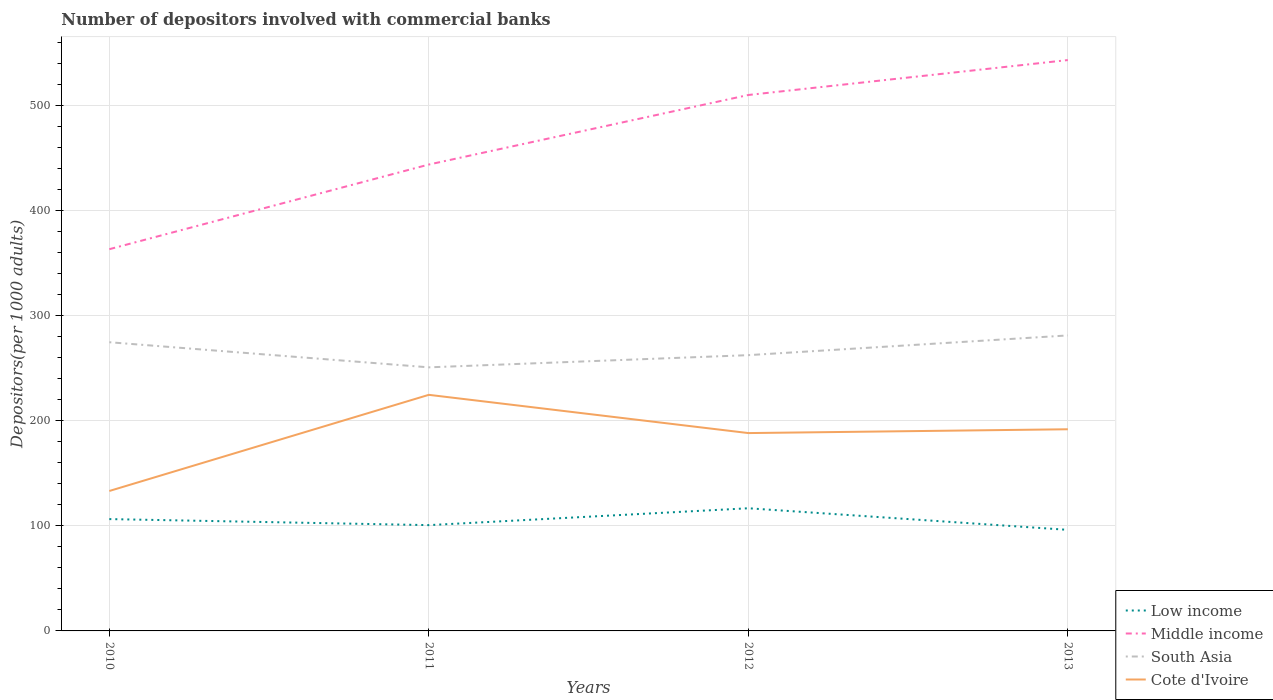Across all years, what is the maximum number of depositors involved with commercial banks in Middle income?
Give a very brief answer. 363.5. In which year was the number of depositors involved with commercial banks in Middle income maximum?
Ensure brevity in your answer.  2010. What is the total number of depositors involved with commercial banks in South Asia in the graph?
Your answer should be compact. 12.31. What is the difference between the highest and the second highest number of depositors involved with commercial banks in Low income?
Provide a succinct answer. 20.56. What is the difference between the highest and the lowest number of depositors involved with commercial banks in Low income?
Your answer should be compact. 2. Is the number of depositors involved with commercial banks in South Asia strictly greater than the number of depositors involved with commercial banks in Middle income over the years?
Make the answer very short. Yes. How many lines are there?
Your answer should be compact. 4. What is the difference between two consecutive major ticks on the Y-axis?
Your response must be concise. 100. Are the values on the major ticks of Y-axis written in scientific E-notation?
Your answer should be compact. No. Where does the legend appear in the graph?
Provide a short and direct response. Bottom right. How are the legend labels stacked?
Your response must be concise. Vertical. What is the title of the graph?
Your answer should be very brief. Number of depositors involved with commercial banks. What is the label or title of the X-axis?
Your answer should be compact. Years. What is the label or title of the Y-axis?
Keep it short and to the point. Depositors(per 1000 adults). What is the Depositors(per 1000 adults) of Low income in 2010?
Provide a succinct answer. 106.49. What is the Depositors(per 1000 adults) in Middle income in 2010?
Keep it short and to the point. 363.5. What is the Depositors(per 1000 adults) in South Asia in 2010?
Your response must be concise. 274.9. What is the Depositors(per 1000 adults) in Cote d'Ivoire in 2010?
Your answer should be very brief. 133.26. What is the Depositors(per 1000 adults) of Low income in 2011?
Provide a succinct answer. 100.75. What is the Depositors(per 1000 adults) in Middle income in 2011?
Make the answer very short. 444.11. What is the Depositors(per 1000 adults) of South Asia in 2011?
Ensure brevity in your answer.  250.99. What is the Depositors(per 1000 adults) of Cote d'Ivoire in 2011?
Keep it short and to the point. 224.81. What is the Depositors(per 1000 adults) in Low income in 2012?
Provide a succinct answer. 116.8. What is the Depositors(per 1000 adults) of Middle income in 2012?
Give a very brief answer. 510.34. What is the Depositors(per 1000 adults) in South Asia in 2012?
Offer a terse response. 262.6. What is the Depositors(per 1000 adults) in Cote d'Ivoire in 2012?
Ensure brevity in your answer.  188.4. What is the Depositors(per 1000 adults) in Low income in 2013?
Keep it short and to the point. 96.24. What is the Depositors(per 1000 adults) of Middle income in 2013?
Provide a succinct answer. 543.59. What is the Depositors(per 1000 adults) in South Asia in 2013?
Your response must be concise. 281.38. What is the Depositors(per 1000 adults) in Cote d'Ivoire in 2013?
Offer a terse response. 192.03. Across all years, what is the maximum Depositors(per 1000 adults) in Low income?
Ensure brevity in your answer.  116.8. Across all years, what is the maximum Depositors(per 1000 adults) of Middle income?
Provide a short and direct response. 543.59. Across all years, what is the maximum Depositors(per 1000 adults) of South Asia?
Your response must be concise. 281.38. Across all years, what is the maximum Depositors(per 1000 adults) in Cote d'Ivoire?
Your answer should be very brief. 224.81. Across all years, what is the minimum Depositors(per 1000 adults) of Low income?
Offer a terse response. 96.24. Across all years, what is the minimum Depositors(per 1000 adults) of Middle income?
Offer a very short reply. 363.5. Across all years, what is the minimum Depositors(per 1000 adults) of South Asia?
Give a very brief answer. 250.99. Across all years, what is the minimum Depositors(per 1000 adults) of Cote d'Ivoire?
Your answer should be compact. 133.26. What is the total Depositors(per 1000 adults) of Low income in the graph?
Give a very brief answer. 420.28. What is the total Depositors(per 1000 adults) of Middle income in the graph?
Provide a short and direct response. 1861.53. What is the total Depositors(per 1000 adults) of South Asia in the graph?
Your response must be concise. 1069.88. What is the total Depositors(per 1000 adults) in Cote d'Ivoire in the graph?
Make the answer very short. 738.5. What is the difference between the Depositors(per 1000 adults) in Low income in 2010 and that in 2011?
Provide a succinct answer. 5.74. What is the difference between the Depositors(per 1000 adults) of Middle income in 2010 and that in 2011?
Your answer should be very brief. -80.61. What is the difference between the Depositors(per 1000 adults) in South Asia in 2010 and that in 2011?
Your answer should be compact. 23.91. What is the difference between the Depositors(per 1000 adults) in Cote d'Ivoire in 2010 and that in 2011?
Your answer should be compact. -91.56. What is the difference between the Depositors(per 1000 adults) in Low income in 2010 and that in 2012?
Your response must be concise. -10.31. What is the difference between the Depositors(per 1000 adults) of Middle income in 2010 and that in 2012?
Your answer should be very brief. -146.84. What is the difference between the Depositors(per 1000 adults) in South Asia in 2010 and that in 2012?
Ensure brevity in your answer.  12.31. What is the difference between the Depositors(per 1000 adults) in Cote d'Ivoire in 2010 and that in 2012?
Offer a terse response. -55.14. What is the difference between the Depositors(per 1000 adults) of Low income in 2010 and that in 2013?
Give a very brief answer. 10.25. What is the difference between the Depositors(per 1000 adults) of Middle income in 2010 and that in 2013?
Ensure brevity in your answer.  -180.09. What is the difference between the Depositors(per 1000 adults) in South Asia in 2010 and that in 2013?
Ensure brevity in your answer.  -6.48. What is the difference between the Depositors(per 1000 adults) in Cote d'Ivoire in 2010 and that in 2013?
Your answer should be compact. -58.78. What is the difference between the Depositors(per 1000 adults) of Low income in 2011 and that in 2012?
Offer a terse response. -16.05. What is the difference between the Depositors(per 1000 adults) of Middle income in 2011 and that in 2012?
Your answer should be compact. -66.23. What is the difference between the Depositors(per 1000 adults) of South Asia in 2011 and that in 2012?
Keep it short and to the point. -11.61. What is the difference between the Depositors(per 1000 adults) of Cote d'Ivoire in 2011 and that in 2012?
Your answer should be compact. 36.42. What is the difference between the Depositors(per 1000 adults) in Low income in 2011 and that in 2013?
Provide a short and direct response. 4.5. What is the difference between the Depositors(per 1000 adults) in Middle income in 2011 and that in 2013?
Offer a terse response. -99.48. What is the difference between the Depositors(per 1000 adults) of South Asia in 2011 and that in 2013?
Your answer should be compact. -30.39. What is the difference between the Depositors(per 1000 adults) in Cote d'Ivoire in 2011 and that in 2013?
Give a very brief answer. 32.78. What is the difference between the Depositors(per 1000 adults) in Low income in 2012 and that in 2013?
Provide a short and direct response. 20.56. What is the difference between the Depositors(per 1000 adults) in Middle income in 2012 and that in 2013?
Keep it short and to the point. -33.25. What is the difference between the Depositors(per 1000 adults) of South Asia in 2012 and that in 2013?
Keep it short and to the point. -18.78. What is the difference between the Depositors(per 1000 adults) of Cote d'Ivoire in 2012 and that in 2013?
Provide a short and direct response. -3.63. What is the difference between the Depositors(per 1000 adults) in Low income in 2010 and the Depositors(per 1000 adults) in Middle income in 2011?
Ensure brevity in your answer.  -337.62. What is the difference between the Depositors(per 1000 adults) in Low income in 2010 and the Depositors(per 1000 adults) in South Asia in 2011?
Your answer should be very brief. -144.5. What is the difference between the Depositors(per 1000 adults) of Low income in 2010 and the Depositors(per 1000 adults) of Cote d'Ivoire in 2011?
Give a very brief answer. -118.32. What is the difference between the Depositors(per 1000 adults) in Middle income in 2010 and the Depositors(per 1000 adults) in South Asia in 2011?
Provide a short and direct response. 112.5. What is the difference between the Depositors(per 1000 adults) of Middle income in 2010 and the Depositors(per 1000 adults) of Cote d'Ivoire in 2011?
Provide a succinct answer. 138.68. What is the difference between the Depositors(per 1000 adults) of South Asia in 2010 and the Depositors(per 1000 adults) of Cote d'Ivoire in 2011?
Your answer should be compact. 50.09. What is the difference between the Depositors(per 1000 adults) in Low income in 2010 and the Depositors(per 1000 adults) in Middle income in 2012?
Offer a very short reply. -403.85. What is the difference between the Depositors(per 1000 adults) of Low income in 2010 and the Depositors(per 1000 adults) of South Asia in 2012?
Provide a succinct answer. -156.11. What is the difference between the Depositors(per 1000 adults) of Low income in 2010 and the Depositors(per 1000 adults) of Cote d'Ivoire in 2012?
Your answer should be compact. -81.91. What is the difference between the Depositors(per 1000 adults) in Middle income in 2010 and the Depositors(per 1000 adults) in South Asia in 2012?
Offer a very short reply. 100.9. What is the difference between the Depositors(per 1000 adults) of Middle income in 2010 and the Depositors(per 1000 adults) of Cote d'Ivoire in 2012?
Your answer should be compact. 175.1. What is the difference between the Depositors(per 1000 adults) in South Asia in 2010 and the Depositors(per 1000 adults) in Cote d'Ivoire in 2012?
Your response must be concise. 86.51. What is the difference between the Depositors(per 1000 adults) in Low income in 2010 and the Depositors(per 1000 adults) in Middle income in 2013?
Your answer should be compact. -437.1. What is the difference between the Depositors(per 1000 adults) in Low income in 2010 and the Depositors(per 1000 adults) in South Asia in 2013?
Your answer should be very brief. -174.89. What is the difference between the Depositors(per 1000 adults) of Low income in 2010 and the Depositors(per 1000 adults) of Cote d'Ivoire in 2013?
Offer a terse response. -85.54. What is the difference between the Depositors(per 1000 adults) in Middle income in 2010 and the Depositors(per 1000 adults) in South Asia in 2013?
Your answer should be compact. 82.12. What is the difference between the Depositors(per 1000 adults) in Middle income in 2010 and the Depositors(per 1000 adults) in Cote d'Ivoire in 2013?
Your answer should be compact. 171.47. What is the difference between the Depositors(per 1000 adults) of South Asia in 2010 and the Depositors(per 1000 adults) of Cote d'Ivoire in 2013?
Your response must be concise. 82.87. What is the difference between the Depositors(per 1000 adults) of Low income in 2011 and the Depositors(per 1000 adults) of Middle income in 2012?
Make the answer very short. -409.59. What is the difference between the Depositors(per 1000 adults) of Low income in 2011 and the Depositors(per 1000 adults) of South Asia in 2012?
Offer a very short reply. -161.85. What is the difference between the Depositors(per 1000 adults) in Low income in 2011 and the Depositors(per 1000 adults) in Cote d'Ivoire in 2012?
Ensure brevity in your answer.  -87.65. What is the difference between the Depositors(per 1000 adults) in Middle income in 2011 and the Depositors(per 1000 adults) in South Asia in 2012?
Provide a short and direct response. 181.51. What is the difference between the Depositors(per 1000 adults) in Middle income in 2011 and the Depositors(per 1000 adults) in Cote d'Ivoire in 2012?
Keep it short and to the point. 255.71. What is the difference between the Depositors(per 1000 adults) in South Asia in 2011 and the Depositors(per 1000 adults) in Cote d'Ivoire in 2012?
Offer a terse response. 62.6. What is the difference between the Depositors(per 1000 adults) of Low income in 2011 and the Depositors(per 1000 adults) of Middle income in 2013?
Keep it short and to the point. -442.84. What is the difference between the Depositors(per 1000 adults) of Low income in 2011 and the Depositors(per 1000 adults) of South Asia in 2013?
Make the answer very short. -180.63. What is the difference between the Depositors(per 1000 adults) of Low income in 2011 and the Depositors(per 1000 adults) of Cote d'Ivoire in 2013?
Give a very brief answer. -91.28. What is the difference between the Depositors(per 1000 adults) in Middle income in 2011 and the Depositors(per 1000 adults) in South Asia in 2013?
Your answer should be compact. 162.73. What is the difference between the Depositors(per 1000 adults) of Middle income in 2011 and the Depositors(per 1000 adults) of Cote d'Ivoire in 2013?
Your answer should be compact. 252.08. What is the difference between the Depositors(per 1000 adults) of South Asia in 2011 and the Depositors(per 1000 adults) of Cote d'Ivoire in 2013?
Offer a terse response. 58.96. What is the difference between the Depositors(per 1000 adults) in Low income in 2012 and the Depositors(per 1000 adults) in Middle income in 2013?
Provide a succinct answer. -426.79. What is the difference between the Depositors(per 1000 adults) in Low income in 2012 and the Depositors(per 1000 adults) in South Asia in 2013?
Your answer should be compact. -164.58. What is the difference between the Depositors(per 1000 adults) of Low income in 2012 and the Depositors(per 1000 adults) of Cote d'Ivoire in 2013?
Provide a short and direct response. -75.23. What is the difference between the Depositors(per 1000 adults) of Middle income in 2012 and the Depositors(per 1000 adults) of South Asia in 2013?
Ensure brevity in your answer.  228.96. What is the difference between the Depositors(per 1000 adults) of Middle income in 2012 and the Depositors(per 1000 adults) of Cote d'Ivoire in 2013?
Ensure brevity in your answer.  318.3. What is the difference between the Depositors(per 1000 adults) in South Asia in 2012 and the Depositors(per 1000 adults) in Cote d'Ivoire in 2013?
Offer a very short reply. 70.57. What is the average Depositors(per 1000 adults) of Low income per year?
Provide a succinct answer. 105.07. What is the average Depositors(per 1000 adults) in Middle income per year?
Ensure brevity in your answer.  465.38. What is the average Depositors(per 1000 adults) of South Asia per year?
Offer a terse response. 267.47. What is the average Depositors(per 1000 adults) of Cote d'Ivoire per year?
Offer a very short reply. 184.62. In the year 2010, what is the difference between the Depositors(per 1000 adults) in Low income and Depositors(per 1000 adults) in Middle income?
Make the answer very short. -257.01. In the year 2010, what is the difference between the Depositors(per 1000 adults) of Low income and Depositors(per 1000 adults) of South Asia?
Your answer should be very brief. -168.41. In the year 2010, what is the difference between the Depositors(per 1000 adults) in Low income and Depositors(per 1000 adults) in Cote d'Ivoire?
Make the answer very short. -26.77. In the year 2010, what is the difference between the Depositors(per 1000 adults) in Middle income and Depositors(per 1000 adults) in South Asia?
Give a very brief answer. 88.59. In the year 2010, what is the difference between the Depositors(per 1000 adults) of Middle income and Depositors(per 1000 adults) of Cote d'Ivoire?
Your answer should be very brief. 230.24. In the year 2010, what is the difference between the Depositors(per 1000 adults) of South Asia and Depositors(per 1000 adults) of Cote d'Ivoire?
Your response must be concise. 141.65. In the year 2011, what is the difference between the Depositors(per 1000 adults) of Low income and Depositors(per 1000 adults) of Middle income?
Your response must be concise. -343.36. In the year 2011, what is the difference between the Depositors(per 1000 adults) in Low income and Depositors(per 1000 adults) in South Asia?
Offer a very short reply. -150.25. In the year 2011, what is the difference between the Depositors(per 1000 adults) in Low income and Depositors(per 1000 adults) in Cote d'Ivoire?
Offer a terse response. -124.07. In the year 2011, what is the difference between the Depositors(per 1000 adults) of Middle income and Depositors(per 1000 adults) of South Asia?
Your answer should be very brief. 193.12. In the year 2011, what is the difference between the Depositors(per 1000 adults) in Middle income and Depositors(per 1000 adults) in Cote d'Ivoire?
Your response must be concise. 219.3. In the year 2011, what is the difference between the Depositors(per 1000 adults) of South Asia and Depositors(per 1000 adults) of Cote d'Ivoire?
Offer a very short reply. 26.18. In the year 2012, what is the difference between the Depositors(per 1000 adults) in Low income and Depositors(per 1000 adults) in Middle income?
Offer a terse response. -393.54. In the year 2012, what is the difference between the Depositors(per 1000 adults) of Low income and Depositors(per 1000 adults) of South Asia?
Your answer should be compact. -145.8. In the year 2012, what is the difference between the Depositors(per 1000 adults) in Low income and Depositors(per 1000 adults) in Cote d'Ivoire?
Provide a succinct answer. -71.6. In the year 2012, what is the difference between the Depositors(per 1000 adults) in Middle income and Depositors(per 1000 adults) in South Asia?
Provide a succinct answer. 247.74. In the year 2012, what is the difference between the Depositors(per 1000 adults) of Middle income and Depositors(per 1000 adults) of Cote d'Ivoire?
Keep it short and to the point. 321.94. In the year 2012, what is the difference between the Depositors(per 1000 adults) of South Asia and Depositors(per 1000 adults) of Cote d'Ivoire?
Make the answer very short. 74.2. In the year 2013, what is the difference between the Depositors(per 1000 adults) in Low income and Depositors(per 1000 adults) in Middle income?
Provide a succinct answer. -447.35. In the year 2013, what is the difference between the Depositors(per 1000 adults) of Low income and Depositors(per 1000 adults) of South Asia?
Offer a terse response. -185.14. In the year 2013, what is the difference between the Depositors(per 1000 adults) of Low income and Depositors(per 1000 adults) of Cote d'Ivoire?
Provide a succinct answer. -95.79. In the year 2013, what is the difference between the Depositors(per 1000 adults) of Middle income and Depositors(per 1000 adults) of South Asia?
Provide a succinct answer. 262.21. In the year 2013, what is the difference between the Depositors(per 1000 adults) of Middle income and Depositors(per 1000 adults) of Cote d'Ivoire?
Ensure brevity in your answer.  351.56. In the year 2013, what is the difference between the Depositors(per 1000 adults) of South Asia and Depositors(per 1000 adults) of Cote d'Ivoire?
Provide a succinct answer. 89.35. What is the ratio of the Depositors(per 1000 adults) in Low income in 2010 to that in 2011?
Give a very brief answer. 1.06. What is the ratio of the Depositors(per 1000 adults) of Middle income in 2010 to that in 2011?
Provide a short and direct response. 0.82. What is the ratio of the Depositors(per 1000 adults) in South Asia in 2010 to that in 2011?
Your answer should be compact. 1.1. What is the ratio of the Depositors(per 1000 adults) of Cote d'Ivoire in 2010 to that in 2011?
Ensure brevity in your answer.  0.59. What is the ratio of the Depositors(per 1000 adults) in Low income in 2010 to that in 2012?
Your answer should be compact. 0.91. What is the ratio of the Depositors(per 1000 adults) of Middle income in 2010 to that in 2012?
Your response must be concise. 0.71. What is the ratio of the Depositors(per 1000 adults) in South Asia in 2010 to that in 2012?
Ensure brevity in your answer.  1.05. What is the ratio of the Depositors(per 1000 adults) of Cote d'Ivoire in 2010 to that in 2012?
Your answer should be very brief. 0.71. What is the ratio of the Depositors(per 1000 adults) of Low income in 2010 to that in 2013?
Give a very brief answer. 1.11. What is the ratio of the Depositors(per 1000 adults) of Middle income in 2010 to that in 2013?
Keep it short and to the point. 0.67. What is the ratio of the Depositors(per 1000 adults) of South Asia in 2010 to that in 2013?
Your response must be concise. 0.98. What is the ratio of the Depositors(per 1000 adults) of Cote d'Ivoire in 2010 to that in 2013?
Ensure brevity in your answer.  0.69. What is the ratio of the Depositors(per 1000 adults) of Low income in 2011 to that in 2012?
Keep it short and to the point. 0.86. What is the ratio of the Depositors(per 1000 adults) of Middle income in 2011 to that in 2012?
Keep it short and to the point. 0.87. What is the ratio of the Depositors(per 1000 adults) in South Asia in 2011 to that in 2012?
Offer a terse response. 0.96. What is the ratio of the Depositors(per 1000 adults) of Cote d'Ivoire in 2011 to that in 2012?
Give a very brief answer. 1.19. What is the ratio of the Depositors(per 1000 adults) of Low income in 2011 to that in 2013?
Make the answer very short. 1.05. What is the ratio of the Depositors(per 1000 adults) in Middle income in 2011 to that in 2013?
Your answer should be compact. 0.82. What is the ratio of the Depositors(per 1000 adults) of South Asia in 2011 to that in 2013?
Provide a short and direct response. 0.89. What is the ratio of the Depositors(per 1000 adults) in Cote d'Ivoire in 2011 to that in 2013?
Ensure brevity in your answer.  1.17. What is the ratio of the Depositors(per 1000 adults) of Low income in 2012 to that in 2013?
Offer a terse response. 1.21. What is the ratio of the Depositors(per 1000 adults) in Middle income in 2012 to that in 2013?
Give a very brief answer. 0.94. What is the ratio of the Depositors(per 1000 adults) of Cote d'Ivoire in 2012 to that in 2013?
Provide a succinct answer. 0.98. What is the difference between the highest and the second highest Depositors(per 1000 adults) in Low income?
Provide a short and direct response. 10.31. What is the difference between the highest and the second highest Depositors(per 1000 adults) in Middle income?
Make the answer very short. 33.25. What is the difference between the highest and the second highest Depositors(per 1000 adults) of South Asia?
Give a very brief answer. 6.48. What is the difference between the highest and the second highest Depositors(per 1000 adults) in Cote d'Ivoire?
Your answer should be compact. 32.78. What is the difference between the highest and the lowest Depositors(per 1000 adults) in Low income?
Offer a very short reply. 20.56. What is the difference between the highest and the lowest Depositors(per 1000 adults) of Middle income?
Your response must be concise. 180.09. What is the difference between the highest and the lowest Depositors(per 1000 adults) in South Asia?
Make the answer very short. 30.39. What is the difference between the highest and the lowest Depositors(per 1000 adults) in Cote d'Ivoire?
Your answer should be compact. 91.56. 